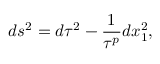Convert formula to latex. <formula><loc_0><loc_0><loc_500><loc_500>d s ^ { 2 } = d \tau ^ { 2 } - { \frac { 1 } { \tau ^ { p } } } d x _ { 1 } ^ { 2 } ,</formula> 